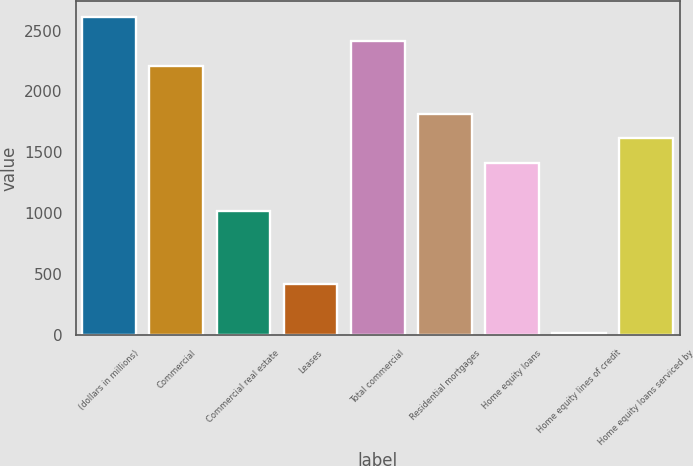<chart> <loc_0><loc_0><loc_500><loc_500><bar_chart><fcel>(dollars in millions)<fcel>Commercial<fcel>Commercial real estate<fcel>Leases<fcel>Total commercial<fcel>Residential mortgages<fcel>Home equity loans<fcel>Home equity lines of credit<fcel>Home equity loans serviced by<nl><fcel>2611.5<fcel>2212.5<fcel>1015.5<fcel>417<fcel>2412<fcel>1813.5<fcel>1414.5<fcel>18<fcel>1614<nl></chart> 